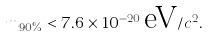Convert formula to latex. <formula><loc_0><loc_0><loc_500><loc_500>m _ { 9 0 \% } < 7 . 6 \times 1 0 ^ { - 2 0 } \, \text {eV} / c ^ { 2 } .</formula> 